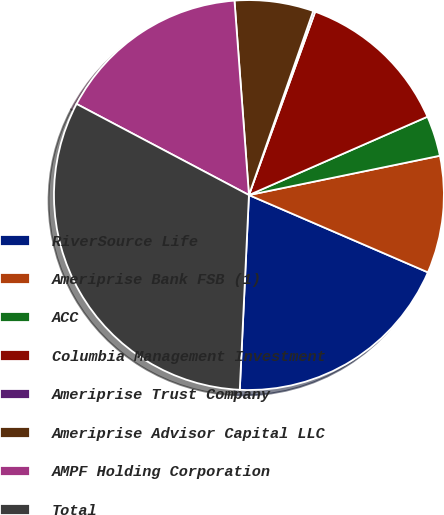Convert chart. <chart><loc_0><loc_0><loc_500><loc_500><pie_chart><fcel>RiverSource Life<fcel>Ameriprise Bank FSB (1)<fcel>ACC<fcel>Columbia Management Investment<fcel>Ameriprise Trust Company<fcel>Ameriprise Advisor Capital LLC<fcel>AMPF Holding Corporation<fcel>Total<nl><fcel>19.26%<fcel>9.72%<fcel>3.35%<fcel>12.9%<fcel>0.17%<fcel>6.53%<fcel>16.08%<fcel>31.99%<nl></chart> 